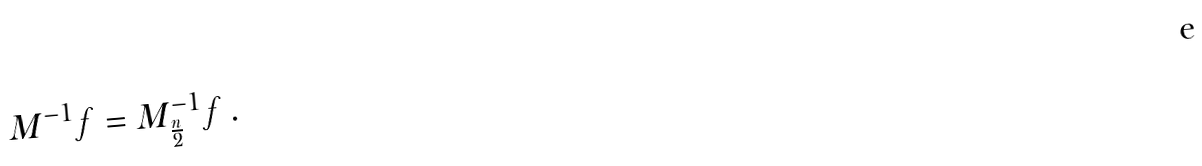<formula> <loc_0><loc_0><loc_500><loc_500>M ^ { - 1 } f = M _ { \frac { n } { 2 } } ^ { - 1 } f \, .</formula> 